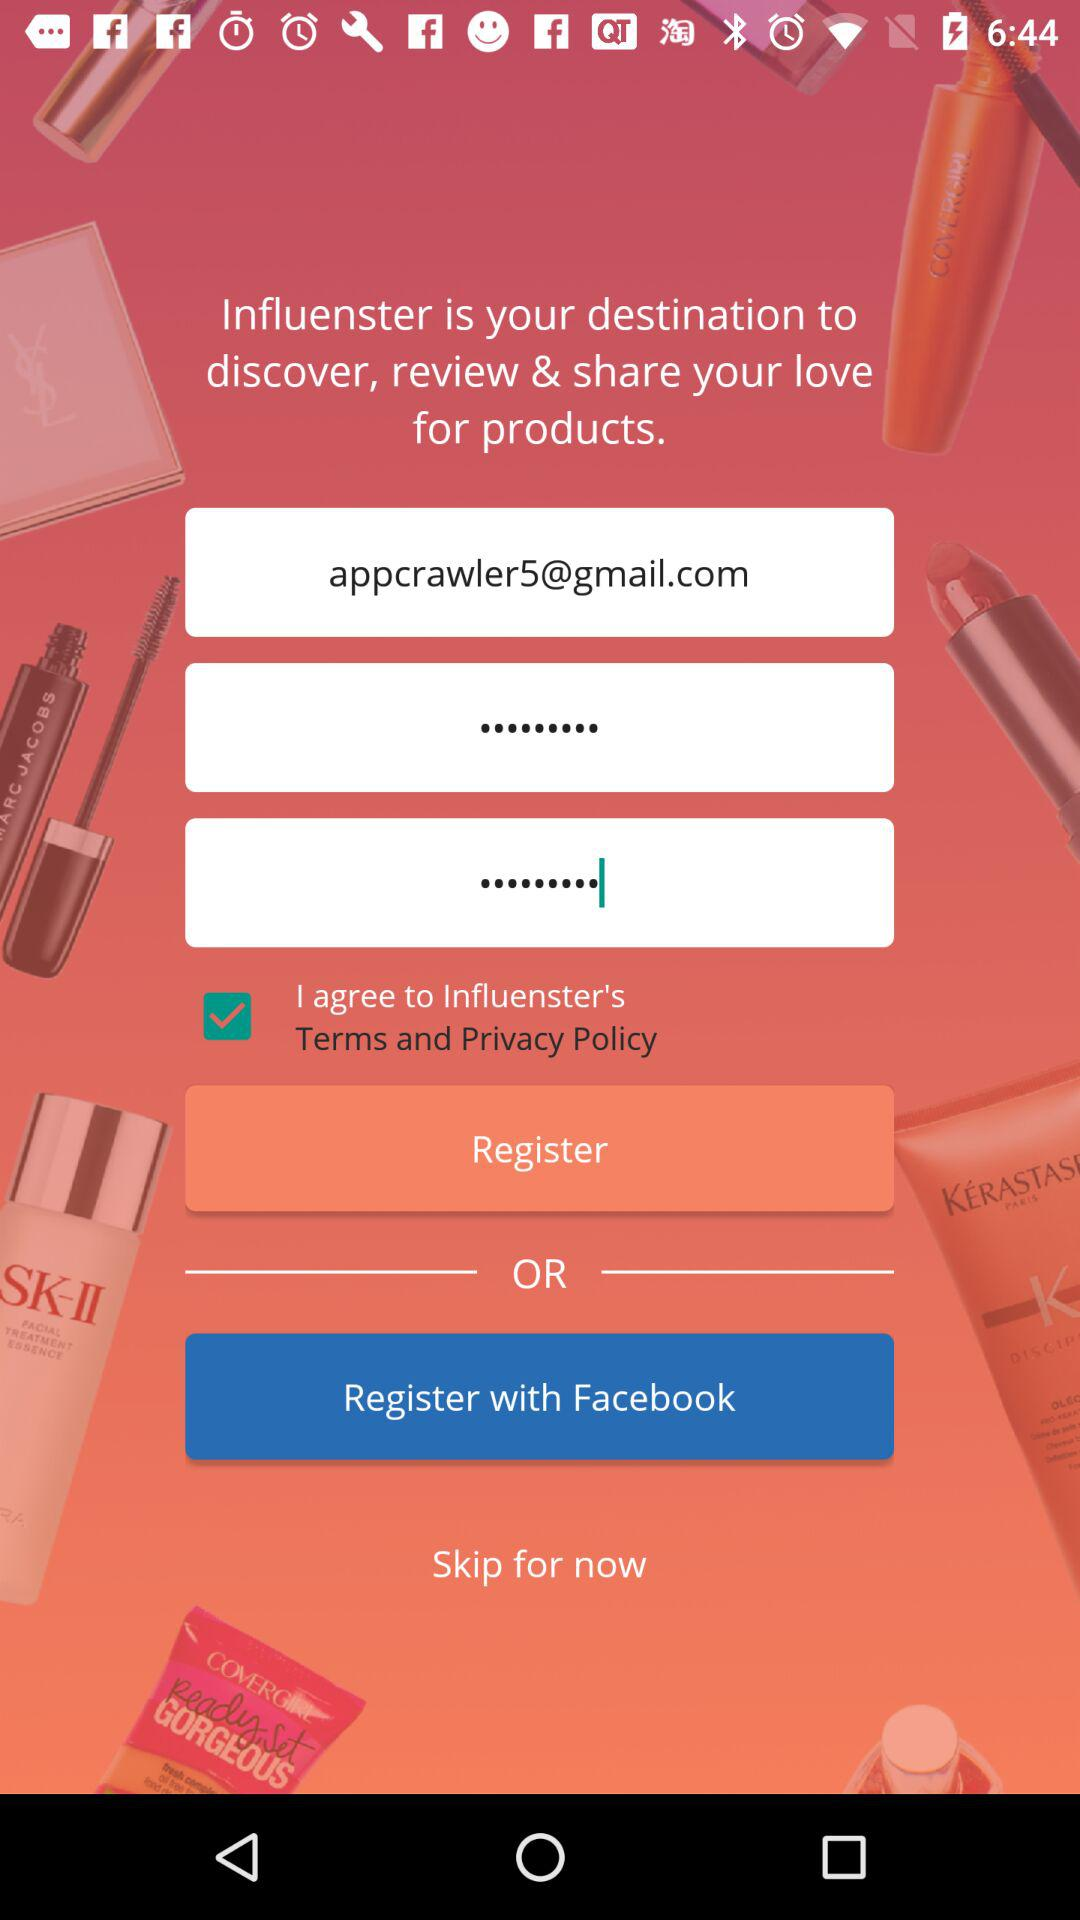How many characters are required for the password?
When the provided information is insufficient, respond with <no answer>. <no answer> 